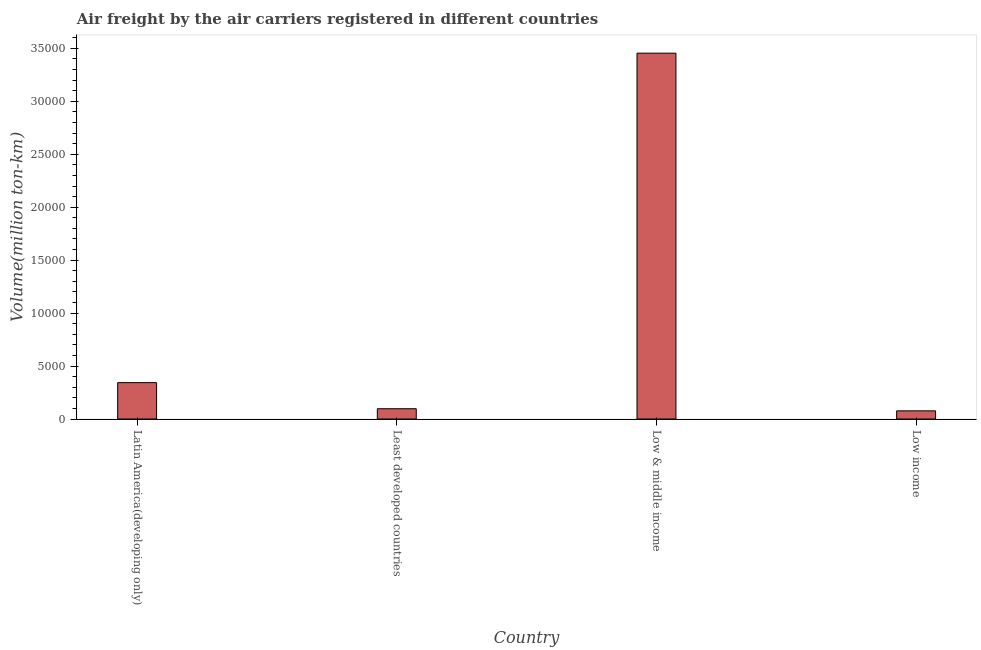Does the graph contain grids?
Your answer should be compact. No. What is the title of the graph?
Provide a short and direct response. Air freight by the air carriers registered in different countries. What is the label or title of the X-axis?
Provide a short and direct response. Country. What is the label or title of the Y-axis?
Ensure brevity in your answer.  Volume(million ton-km). What is the air freight in Low & middle income?
Your answer should be very brief. 3.45e+04. Across all countries, what is the maximum air freight?
Your answer should be compact. 3.45e+04. Across all countries, what is the minimum air freight?
Your answer should be very brief. 771.13. In which country was the air freight maximum?
Give a very brief answer. Low & middle income. What is the sum of the air freight?
Provide a short and direct response. 3.97e+04. What is the difference between the air freight in Least developed countries and Low income?
Your answer should be compact. 200.03. What is the average air freight per country?
Keep it short and to the point. 9930.85. What is the median air freight?
Keep it short and to the point. 2203.37. In how many countries, is the air freight greater than 30000 million ton-km?
Ensure brevity in your answer.  1. What is the ratio of the air freight in Latin America(developing only) to that in Low income?
Provide a succinct answer. 4.46. Is the difference between the air freight in Low & middle income and Low income greater than the difference between any two countries?
Ensure brevity in your answer.  Yes. What is the difference between the highest and the second highest air freight?
Your answer should be compact. 3.11e+04. What is the difference between the highest and the lowest air freight?
Provide a short and direct response. 3.38e+04. How many bars are there?
Your answer should be compact. 4. What is the Volume(million ton-km) of Latin America(developing only)?
Ensure brevity in your answer.  3435.59. What is the Volume(million ton-km) of Least developed countries?
Your response must be concise. 971.15. What is the Volume(million ton-km) in Low & middle income?
Provide a succinct answer. 3.45e+04. What is the Volume(million ton-km) of Low income?
Ensure brevity in your answer.  771.13. What is the difference between the Volume(million ton-km) in Latin America(developing only) and Least developed countries?
Your answer should be very brief. 2464.43. What is the difference between the Volume(million ton-km) in Latin America(developing only) and Low & middle income?
Your response must be concise. -3.11e+04. What is the difference between the Volume(million ton-km) in Latin America(developing only) and Low income?
Make the answer very short. 2664.46. What is the difference between the Volume(million ton-km) in Least developed countries and Low & middle income?
Ensure brevity in your answer.  -3.36e+04. What is the difference between the Volume(million ton-km) in Least developed countries and Low income?
Ensure brevity in your answer.  200.03. What is the difference between the Volume(million ton-km) in Low & middle income and Low income?
Offer a very short reply. 3.38e+04. What is the ratio of the Volume(million ton-km) in Latin America(developing only) to that in Least developed countries?
Provide a succinct answer. 3.54. What is the ratio of the Volume(million ton-km) in Latin America(developing only) to that in Low & middle income?
Ensure brevity in your answer.  0.1. What is the ratio of the Volume(million ton-km) in Latin America(developing only) to that in Low income?
Provide a succinct answer. 4.46. What is the ratio of the Volume(million ton-km) in Least developed countries to that in Low & middle income?
Your answer should be very brief. 0.03. What is the ratio of the Volume(million ton-km) in Least developed countries to that in Low income?
Provide a short and direct response. 1.26. What is the ratio of the Volume(million ton-km) in Low & middle income to that in Low income?
Your answer should be compact. 44.8. 